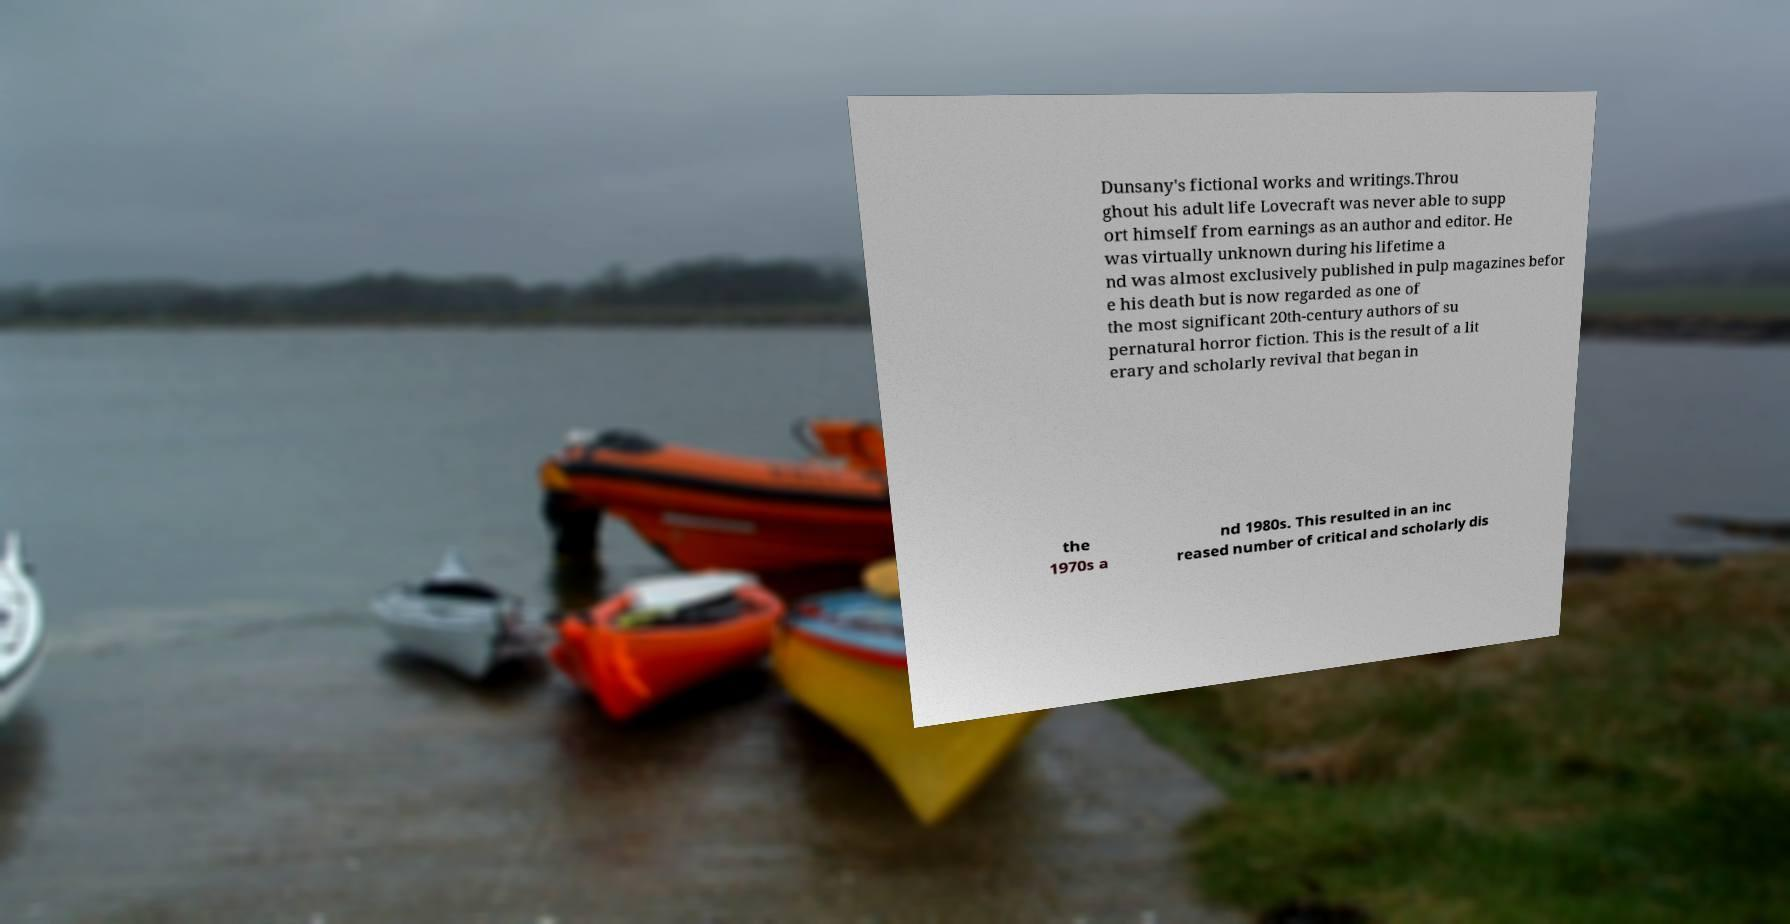I need the written content from this picture converted into text. Can you do that? Dunsany's fictional works and writings.Throu ghout his adult life Lovecraft was never able to supp ort himself from earnings as an author and editor. He was virtually unknown during his lifetime a nd was almost exclusively published in pulp magazines befor e his death but is now regarded as one of the most significant 20th-century authors of su pernatural horror fiction. This is the result of a lit erary and scholarly revival that began in the 1970s a nd 1980s. This resulted in an inc reased number of critical and scholarly dis 